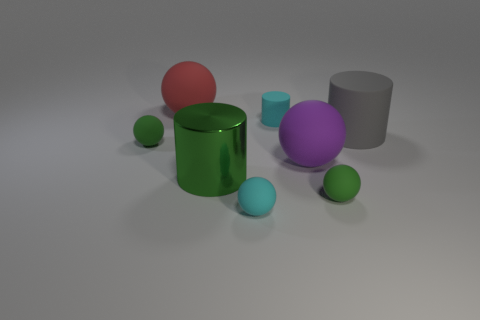What number of other objects are the same color as the small cylinder?
Offer a very short reply. 1. Is there a cylinder that has the same color as the large metallic thing?
Offer a very short reply. No. Does the large rubber sphere in front of the gray cylinder have the same color as the large metal cylinder?
Your response must be concise. No. How many objects are either tiny things that are right of the big red matte sphere or red balls?
Keep it short and to the point. 4. There is a gray matte object; are there any big rubber cylinders in front of it?
Provide a short and direct response. No. There is a thing that is the same color as the small rubber cylinder; what is its material?
Offer a terse response. Rubber. Is the material of the small cyan object in front of the large green shiny cylinder the same as the large gray thing?
Offer a terse response. Yes. Is there a red sphere right of the large rubber sphere on the left side of the cylinder in front of the big gray thing?
Provide a short and direct response. No. What number of blocks are tiny yellow metal things or large purple matte things?
Ensure brevity in your answer.  0. What is the material of the green thing behind the purple ball?
Ensure brevity in your answer.  Rubber. 